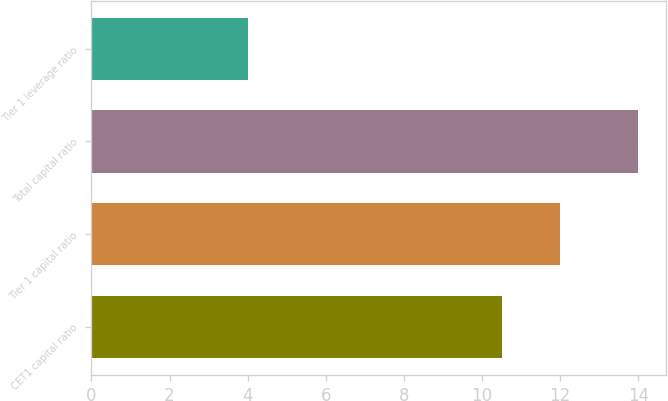Convert chart. <chart><loc_0><loc_0><loc_500><loc_500><bar_chart><fcel>CET1 capital ratio<fcel>Tier 1 capital ratio<fcel>Total capital ratio<fcel>Tier 1 leverage ratio<nl><fcel>10.5<fcel>12<fcel>14<fcel>4<nl></chart> 